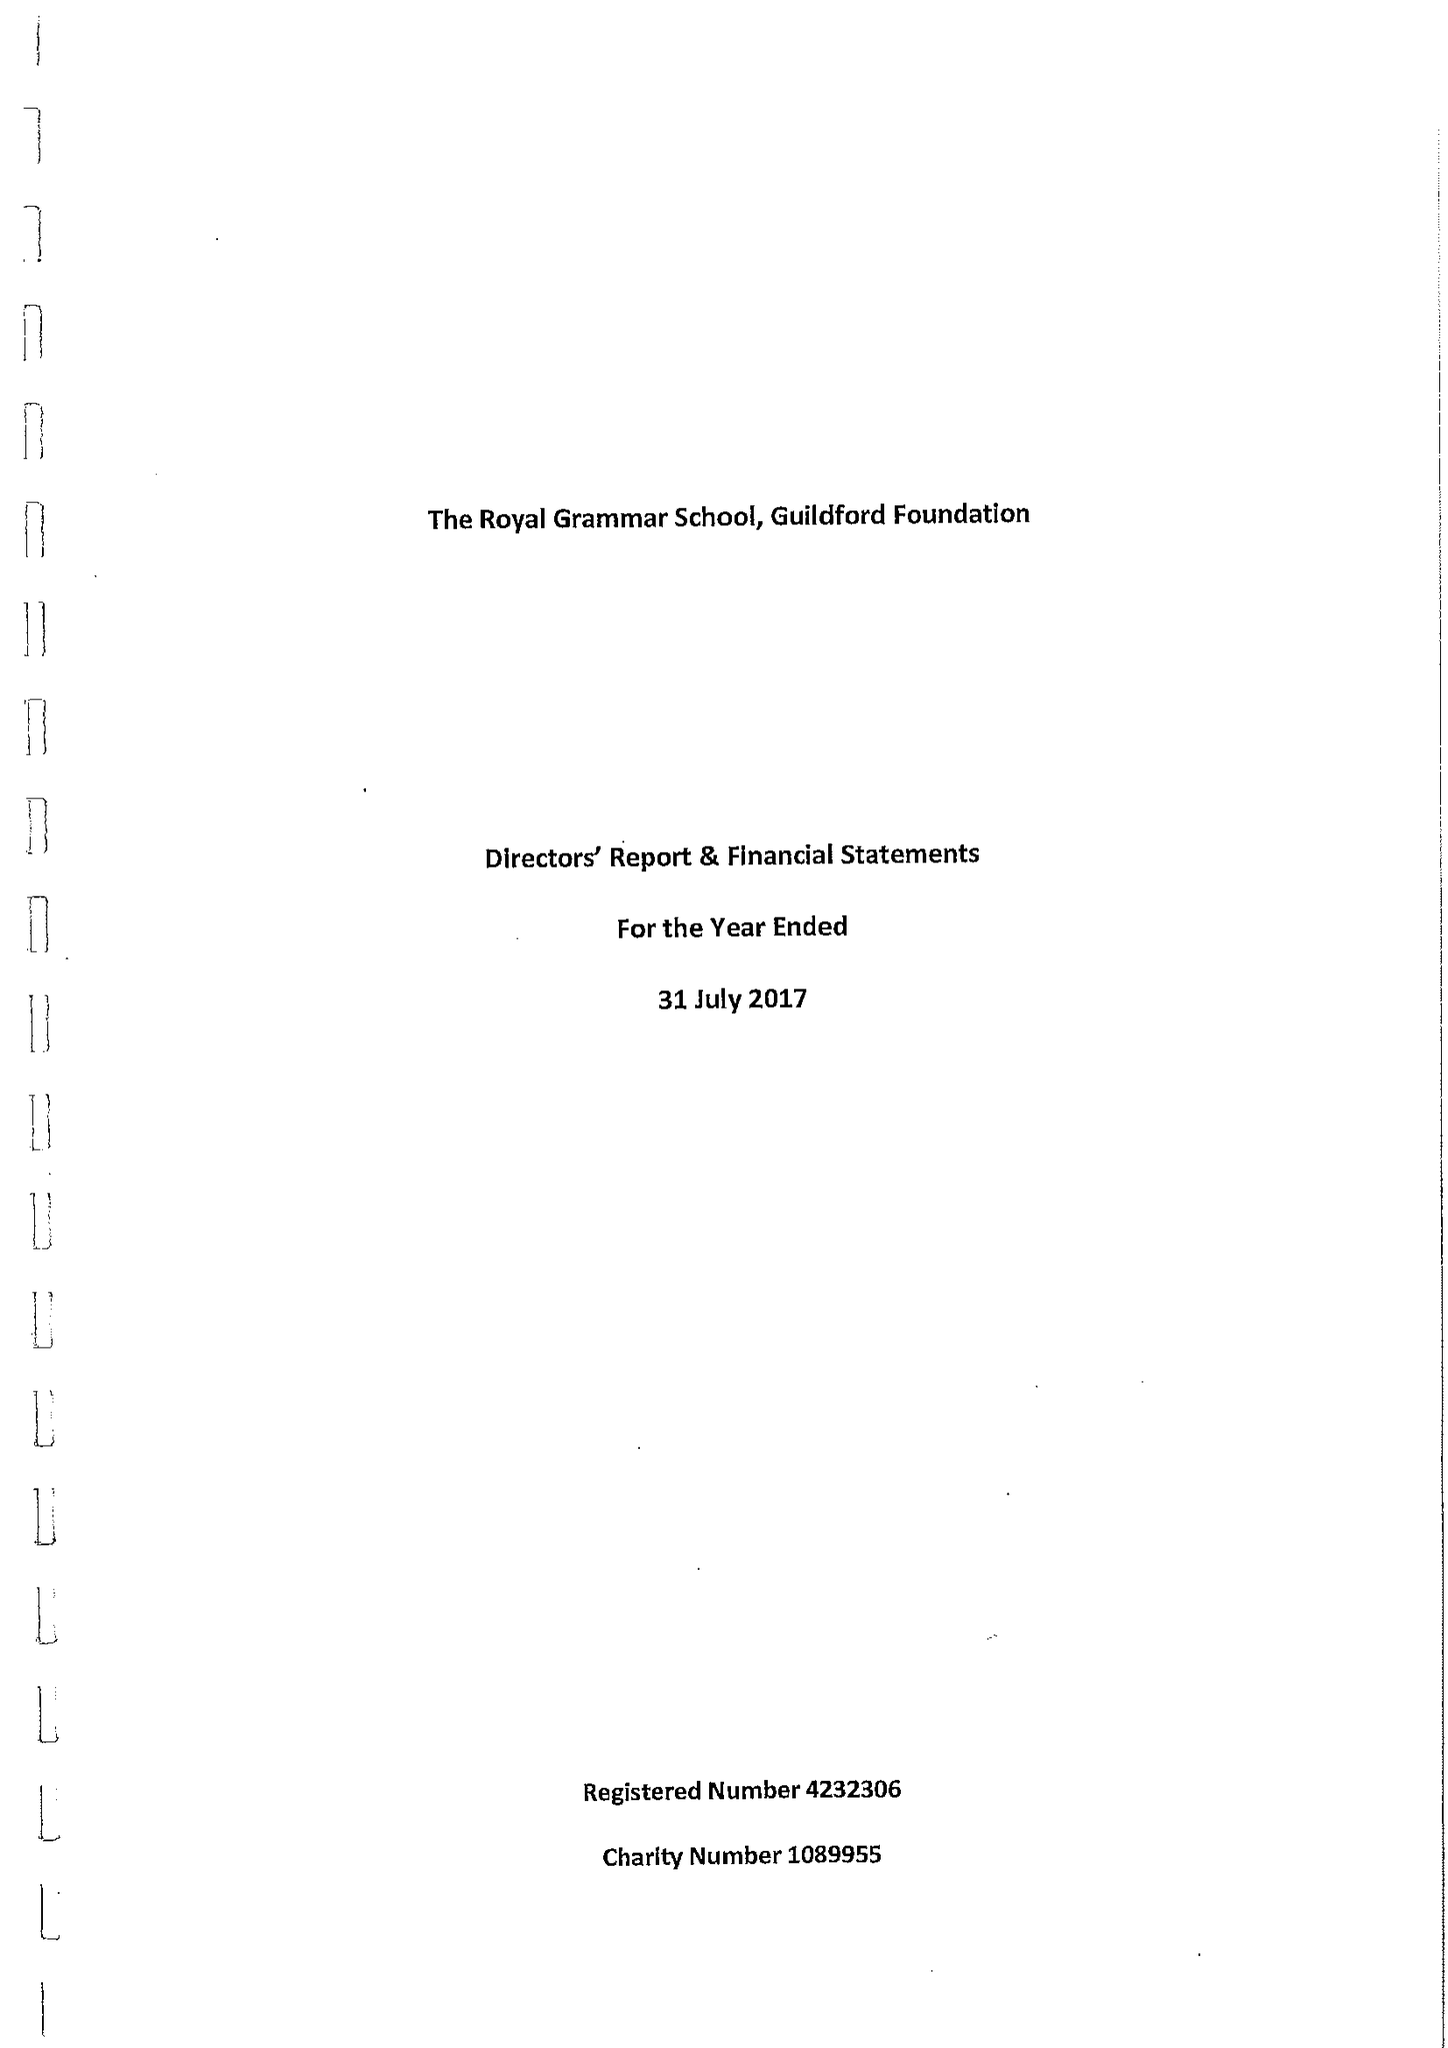What is the value for the spending_annually_in_british_pounds?
Answer the question using a single word or phrase. 149846.00 